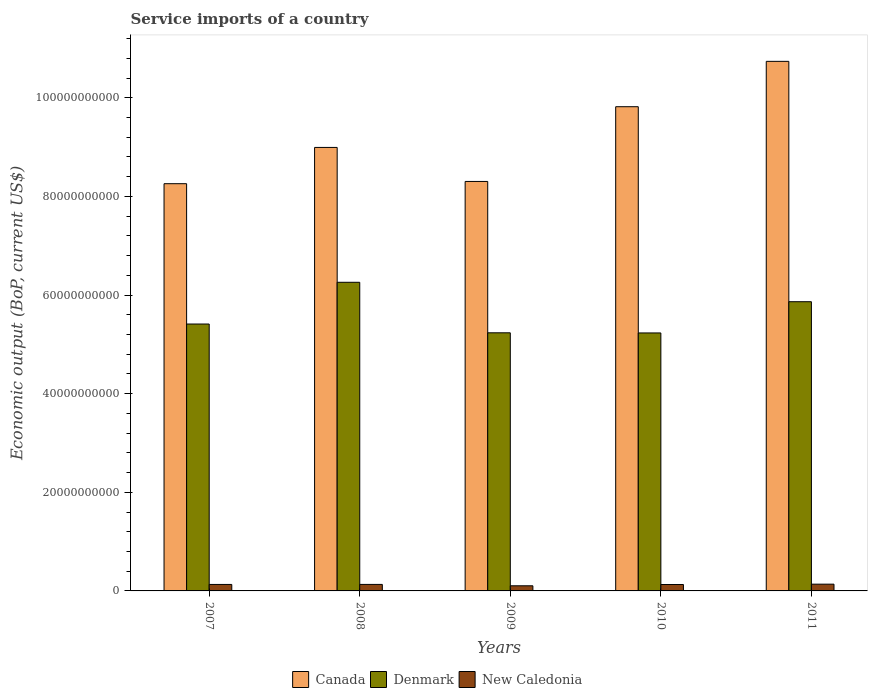How many different coloured bars are there?
Offer a very short reply. 3. Are the number of bars per tick equal to the number of legend labels?
Offer a terse response. Yes. How many bars are there on the 3rd tick from the left?
Give a very brief answer. 3. In how many cases, is the number of bars for a given year not equal to the number of legend labels?
Offer a very short reply. 0. What is the service imports in New Caledonia in 2008?
Provide a succinct answer. 1.32e+09. Across all years, what is the maximum service imports in New Caledonia?
Give a very brief answer. 1.37e+09. Across all years, what is the minimum service imports in New Caledonia?
Your answer should be compact. 1.04e+09. In which year was the service imports in New Caledonia maximum?
Provide a succinct answer. 2011. In which year was the service imports in New Caledonia minimum?
Your answer should be compact. 2009. What is the total service imports in New Caledonia in the graph?
Give a very brief answer. 6.34e+09. What is the difference between the service imports in New Caledonia in 2009 and that in 2010?
Provide a succinct answer. -2.60e+08. What is the difference between the service imports in New Caledonia in 2008 and the service imports in Denmark in 2011?
Give a very brief answer. -5.73e+1. What is the average service imports in Denmark per year?
Provide a succinct answer. 5.60e+1. In the year 2009, what is the difference between the service imports in New Caledonia and service imports in Denmark?
Give a very brief answer. -5.13e+1. In how many years, is the service imports in New Caledonia greater than 104000000000 US$?
Provide a succinct answer. 0. What is the ratio of the service imports in Denmark in 2009 to that in 2010?
Your answer should be very brief. 1. Is the difference between the service imports in New Caledonia in 2009 and 2010 greater than the difference between the service imports in Denmark in 2009 and 2010?
Your response must be concise. No. What is the difference between the highest and the second highest service imports in New Caledonia?
Give a very brief answer. 5.25e+07. What is the difference between the highest and the lowest service imports in New Caledonia?
Your answer should be very brief. 3.31e+08. What does the 1st bar from the left in 2011 represents?
Make the answer very short. Canada. How many bars are there?
Your response must be concise. 15. Are all the bars in the graph horizontal?
Provide a succinct answer. No. How many years are there in the graph?
Offer a very short reply. 5. What is the difference between two consecutive major ticks on the Y-axis?
Provide a short and direct response. 2.00e+1. Are the values on the major ticks of Y-axis written in scientific E-notation?
Provide a succinct answer. No. Does the graph contain grids?
Provide a succinct answer. No. How are the legend labels stacked?
Your answer should be compact. Horizontal. What is the title of the graph?
Make the answer very short. Service imports of a country. What is the label or title of the X-axis?
Provide a succinct answer. Years. What is the label or title of the Y-axis?
Make the answer very short. Economic output (BoP, current US$). What is the Economic output (BoP, current US$) in Canada in 2007?
Keep it short and to the point. 8.26e+1. What is the Economic output (BoP, current US$) in Denmark in 2007?
Offer a very short reply. 5.41e+1. What is the Economic output (BoP, current US$) of New Caledonia in 2007?
Your answer should be compact. 1.31e+09. What is the Economic output (BoP, current US$) in Canada in 2008?
Offer a terse response. 8.99e+1. What is the Economic output (BoP, current US$) of Denmark in 2008?
Offer a very short reply. 6.26e+1. What is the Economic output (BoP, current US$) of New Caledonia in 2008?
Give a very brief answer. 1.32e+09. What is the Economic output (BoP, current US$) in Canada in 2009?
Keep it short and to the point. 8.30e+1. What is the Economic output (BoP, current US$) in Denmark in 2009?
Provide a succinct answer. 5.23e+1. What is the Economic output (BoP, current US$) of New Caledonia in 2009?
Your answer should be very brief. 1.04e+09. What is the Economic output (BoP, current US$) in Canada in 2010?
Provide a succinct answer. 9.82e+1. What is the Economic output (BoP, current US$) of Denmark in 2010?
Ensure brevity in your answer.  5.23e+1. What is the Economic output (BoP, current US$) in New Caledonia in 2010?
Provide a short and direct response. 1.30e+09. What is the Economic output (BoP, current US$) in Canada in 2011?
Ensure brevity in your answer.  1.07e+11. What is the Economic output (BoP, current US$) in Denmark in 2011?
Your response must be concise. 5.86e+1. What is the Economic output (BoP, current US$) of New Caledonia in 2011?
Your answer should be very brief. 1.37e+09. Across all years, what is the maximum Economic output (BoP, current US$) of Canada?
Make the answer very short. 1.07e+11. Across all years, what is the maximum Economic output (BoP, current US$) in Denmark?
Your answer should be very brief. 6.26e+1. Across all years, what is the maximum Economic output (BoP, current US$) in New Caledonia?
Your answer should be compact. 1.37e+09. Across all years, what is the minimum Economic output (BoP, current US$) in Canada?
Provide a short and direct response. 8.26e+1. Across all years, what is the minimum Economic output (BoP, current US$) of Denmark?
Make the answer very short. 5.23e+1. Across all years, what is the minimum Economic output (BoP, current US$) in New Caledonia?
Provide a short and direct response. 1.04e+09. What is the total Economic output (BoP, current US$) of Canada in the graph?
Your response must be concise. 4.61e+11. What is the total Economic output (BoP, current US$) in Denmark in the graph?
Offer a terse response. 2.80e+11. What is the total Economic output (BoP, current US$) of New Caledonia in the graph?
Ensure brevity in your answer.  6.34e+09. What is the difference between the Economic output (BoP, current US$) of Canada in 2007 and that in 2008?
Your answer should be very brief. -7.35e+09. What is the difference between the Economic output (BoP, current US$) of Denmark in 2007 and that in 2008?
Ensure brevity in your answer.  -8.46e+09. What is the difference between the Economic output (BoP, current US$) in New Caledonia in 2007 and that in 2008?
Your answer should be compact. -4.93e+06. What is the difference between the Economic output (BoP, current US$) of Canada in 2007 and that in 2009?
Make the answer very short. -4.55e+08. What is the difference between the Economic output (BoP, current US$) in Denmark in 2007 and that in 2009?
Provide a succinct answer. 1.78e+09. What is the difference between the Economic output (BoP, current US$) of New Caledonia in 2007 and that in 2009?
Ensure brevity in your answer.  2.73e+08. What is the difference between the Economic output (BoP, current US$) of Canada in 2007 and that in 2010?
Ensure brevity in your answer.  -1.56e+1. What is the difference between the Economic output (BoP, current US$) of Denmark in 2007 and that in 2010?
Your answer should be very brief. 1.81e+09. What is the difference between the Economic output (BoP, current US$) of New Caledonia in 2007 and that in 2010?
Offer a very short reply. 1.29e+07. What is the difference between the Economic output (BoP, current US$) of Canada in 2007 and that in 2011?
Keep it short and to the point. -2.48e+1. What is the difference between the Economic output (BoP, current US$) of Denmark in 2007 and that in 2011?
Offer a very short reply. -4.52e+09. What is the difference between the Economic output (BoP, current US$) of New Caledonia in 2007 and that in 2011?
Your answer should be very brief. -5.75e+07. What is the difference between the Economic output (BoP, current US$) in Canada in 2008 and that in 2009?
Your answer should be compact. 6.90e+09. What is the difference between the Economic output (BoP, current US$) in Denmark in 2008 and that in 2009?
Provide a succinct answer. 1.02e+1. What is the difference between the Economic output (BoP, current US$) in New Caledonia in 2008 and that in 2009?
Provide a succinct answer. 2.78e+08. What is the difference between the Economic output (BoP, current US$) of Canada in 2008 and that in 2010?
Give a very brief answer. -8.25e+09. What is the difference between the Economic output (BoP, current US$) in Denmark in 2008 and that in 2010?
Your response must be concise. 1.03e+1. What is the difference between the Economic output (BoP, current US$) of New Caledonia in 2008 and that in 2010?
Your answer should be very brief. 1.78e+07. What is the difference between the Economic output (BoP, current US$) of Canada in 2008 and that in 2011?
Offer a terse response. -1.75e+1. What is the difference between the Economic output (BoP, current US$) in Denmark in 2008 and that in 2011?
Your response must be concise. 3.94e+09. What is the difference between the Economic output (BoP, current US$) of New Caledonia in 2008 and that in 2011?
Offer a very short reply. -5.25e+07. What is the difference between the Economic output (BoP, current US$) in Canada in 2009 and that in 2010?
Your answer should be compact. -1.52e+1. What is the difference between the Economic output (BoP, current US$) in Denmark in 2009 and that in 2010?
Your answer should be very brief. 2.79e+07. What is the difference between the Economic output (BoP, current US$) of New Caledonia in 2009 and that in 2010?
Your answer should be compact. -2.60e+08. What is the difference between the Economic output (BoP, current US$) in Canada in 2009 and that in 2011?
Your response must be concise. -2.44e+1. What is the difference between the Economic output (BoP, current US$) of Denmark in 2009 and that in 2011?
Your answer should be compact. -6.30e+09. What is the difference between the Economic output (BoP, current US$) of New Caledonia in 2009 and that in 2011?
Give a very brief answer. -3.31e+08. What is the difference between the Economic output (BoP, current US$) of Canada in 2010 and that in 2011?
Your answer should be very brief. -9.20e+09. What is the difference between the Economic output (BoP, current US$) of Denmark in 2010 and that in 2011?
Keep it short and to the point. -6.33e+09. What is the difference between the Economic output (BoP, current US$) in New Caledonia in 2010 and that in 2011?
Give a very brief answer. -7.04e+07. What is the difference between the Economic output (BoP, current US$) in Canada in 2007 and the Economic output (BoP, current US$) in Denmark in 2008?
Offer a very short reply. 2.00e+1. What is the difference between the Economic output (BoP, current US$) in Canada in 2007 and the Economic output (BoP, current US$) in New Caledonia in 2008?
Offer a terse response. 8.13e+1. What is the difference between the Economic output (BoP, current US$) in Denmark in 2007 and the Economic output (BoP, current US$) in New Caledonia in 2008?
Offer a very short reply. 5.28e+1. What is the difference between the Economic output (BoP, current US$) in Canada in 2007 and the Economic output (BoP, current US$) in Denmark in 2009?
Your response must be concise. 3.02e+1. What is the difference between the Economic output (BoP, current US$) in Canada in 2007 and the Economic output (BoP, current US$) in New Caledonia in 2009?
Your response must be concise. 8.15e+1. What is the difference between the Economic output (BoP, current US$) of Denmark in 2007 and the Economic output (BoP, current US$) of New Caledonia in 2009?
Provide a succinct answer. 5.31e+1. What is the difference between the Economic output (BoP, current US$) in Canada in 2007 and the Economic output (BoP, current US$) in Denmark in 2010?
Give a very brief answer. 3.03e+1. What is the difference between the Economic output (BoP, current US$) in Canada in 2007 and the Economic output (BoP, current US$) in New Caledonia in 2010?
Offer a terse response. 8.13e+1. What is the difference between the Economic output (BoP, current US$) in Denmark in 2007 and the Economic output (BoP, current US$) in New Caledonia in 2010?
Offer a very short reply. 5.28e+1. What is the difference between the Economic output (BoP, current US$) in Canada in 2007 and the Economic output (BoP, current US$) in Denmark in 2011?
Your response must be concise. 2.39e+1. What is the difference between the Economic output (BoP, current US$) of Canada in 2007 and the Economic output (BoP, current US$) of New Caledonia in 2011?
Your answer should be very brief. 8.12e+1. What is the difference between the Economic output (BoP, current US$) of Denmark in 2007 and the Economic output (BoP, current US$) of New Caledonia in 2011?
Offer a very short reply. 5.27e+1. What is the difference between the Economic output (BoP, current US$) of Canada in 2008 and the Economic output (BoP, current US$) of Denmark in 2009?
Your answer should be very brief. 3.76e+1. What is the difference between the Economic output (BoP, current US$) in Canada in 2008 and the Economic output (BoP, current US$) in New Caledonia in 2009?
Offer a terse response. 8.89e+1. What is the difference between the Economic output (BoP, current US$) of Denmark in 2008 and the Economic output (BoP, current US$) of New Caledonia in 2009?
Your answer should be very brief. 6.15e+1. What is the difference between the Economic output (BoP, current US$) of Canada in 2008 and the Economic output (BoP, current US$) of Denmark in 2010?
Provide a succinct answer. 3.76e+1. What is the difference between the Economic output (BoP, current US$) in Canada in 2008 and the Economic output (BoP, current US$) in New Caledonia in 2010?
Offer a terse response. 8.86e+1. What is the difference between the Economic output (BoP, current US$) in Denmark in 2008 and the Economic output (BoP, current US$) in New Caledonia in 2010?
Your response must be concise. 6.13e+1. What is the difference between the Economic output (BoP, current US$) in Canada in 2008 and the Economic output (BoP, current US$) in Denmark in 2011?
Give a very brief answer. 3.13e+1. What is the difference between the Economic output (BoP, current US$) in Canada in 2008 and the Economic output (BoP, current US$) in New Caledonia in 2011?
Your response must be concise. 8.86e+1. What is the difference between the Economic output (BoP, current US$) in Denmark in 2008 and the Economic output (BoP, current US$) in New Caledonia in 2011?
Keep it short and to the point. 6.12e+1. What is the difference between the Economic output (BoP, current US$) in Canada in 2009 and the Economic output (BoP, current US$) in Denmark in 2010?
Ensure brevity in your answer.  3.07e+1. What is the difference between the Economic output (BoP, current US$) of Canada in 2009 and the Economic output (BoP, current US$) of New Caledonia in 2010?
Offer a very short reply. 8.17e+1. What is the difference between the Economic output (BoP, current US$) of Denmark in 2009 and the Economic output (BoP, current US$) of New Caledonia in 2010?
Your answer should be very brief. 5.10e+1. What is the difference between the Economic output (BoP, current US$) of Canada in 2009 and the Economic output (BoP, current US$) of Denmark in 2011?
Offer a very short reply. 2.44e+1. What is the difference between the Economic output (BoP, current US$) of Canada in 2009 and the Economic output (BoP, current US$) of New Caledonia in 2011?
Offer a very short reply. 8.17e+1. What is the difference between the Economic output (BoP, current US$) of Denmark in 2009 and the Economic output (BoP, current US$) of New Caledonia in 2011?
Make the answer very short. 5.10e+1. What is the difference between the Economic output (BoP, current US$) in Canada in 2010 and the Economic output (BoP, current US$) in Denmark in 2011?
Provide a short and direct response. 3.95e+1. What is the difference between the Economic output (BoP, current US$) in Canada in 2010 and the Economic output (BoP, current US$) in New Caledonia in 2011?
Ensure brevity in your answer.  9.68e+1. What is the difference between the Economic output (BoP, current US$) of Denmark in 2010 and the Economic output (BoP, current US$) of New Caledonia in 2011?
Offer a terse response. 5.09e+1. What is the average Economic output (BoP, current US$) of Canada per year?
Provide a succinct answer. 9.22e+1. What is the average Economic output (BoP, current US$) in Denmark per year?
Your answer should be compact. 5.60e+1. What is the average Economic output (BoP, current US$) in New Caledonia per year?
Make the answer very short. 1.27e+09. In the year 2007, what is the difference between the Economic output (BoP, current US$) in Canada and Economic output (BoP, current US$) in Denmark?
Your response must be concise. 2.85e+1. In the year 2007, what is the difference between the Economic output (BoP, current US$) in Canada and Economic output (BoP, current US$) in New Caledonia?
Keep it short and to the point. 8.13e+1. In the year 2007, what is the difference between the Economic output (BoP, current US$) in Denmark and Economic output (BoP, current US$) in New Caledonia?
Make the answer very short. 5.28e+1. In the year 2008, what is the difference between the Economic output (BoP, current US$) of Canada and Economic output (BoP, current US$) of Denmark?
Provide a succinct answer. 2.73e+1. In the year 2008, what is the difference between the Economic output (BoP, current US$) in Canada and Economic output (BoP, current US$) in New Caledonia?
Ensure brevity in your answer.  8.86e+1. In the year 2008, what is the difference between the Economic output (BoP, current US$) of Denmark and Economic output (BoP, current US$) of New Caledonia?
Your answer should be very brief. 6.13e+1. In the year 2009, what is the difference between the Economic output (BoP, current US$) in Canada and Economic output (BoP, current US$) in Denmark?
Provide a succinct answer. 3.07e+1. In the year 2009, what is the difference between the Economic output (BoP, current US$) in Canada and Economic output (BoP, current US$) in New Caledonia?
Make the answer very short. 8.20e+1. In the year 2009, what is the difference between the Economic output (BoP, current US$) of Denmark and Economic output (BoP, current US$) of New Caledonia?
Your answer should be compact. 5.13e+1. In the year 2010, what is the difference between the Economic output (BoP, current US$) of Canada and Economic output (BoP, current US$) of Denmark?
Provide a succinct answer. 4.59e+1. In the year 2010, what is the difference between the Economic output (BoP, current US$) of Canada and Economic output (BoP, current US$) of New Caledonia?
Provide a succinct answer. 9.69e+1. In the year 2010, what is the difference between the Economic output (BoP, current US$) of Denmark and Economic output (BoP, current US$) of New Caledonia?
Ensure brevity in your answer.  5.10e+1. In the year 2011, what is the difference between the Economic output (BoP, current US$) in Canada and Economic output (BoP, current US$) in Denmark?
Provide a succinct answer. 4.87e+1. In the year 2011, what is the difference between the Economic output (BoP, current US$) in Canada and Economic output (BoP, current US$) in New Caledonia?
Keep it short and to the point. 1.06e+11. In the year 2011, what is the difference between the Economic output (BoP, current US$) of Denmark and Economic output (BoP, current US$) of New Caledonia?
Provide a succinct answer. 5.73e+1. What is the ratio of the Economic output (BoP, current US$) in Canada in 2007 to that in 2008?
Provide a short and direct response. 0.92. What is the ratio of the Economic output (BoP, current US$) of Denmark in 2007 to that in 2008?
Provide a short and direct response. 0.86. What is the ratio of the Economic output (BoP, current US$) of Denmark in 2007 to that in 2009?
Make the answer very short. 1.03. What is the ratio of the Economic output (BoP, current US$) in New Caledonia in 2007 to that in 2009?
Offer a terse response. 1.26. What is the ratio of the Economic output (BoP, current US$) of Canada in 2007 to that in 2010?
Give a very brief answer. 0.84. What is the ratio of the Economic output (BoP, current US$) in Denmark in 2007 to that in 2010?
Offer a very short reply. 1.03. What is the ratio of the Economic output (BoP, current US$) of New Caledonia in 2007 to that in 2010?
Give a very brief answer. 1.01. What is the ratio of the Economic output (BoP, current US$) of Canada in 2007 to that in 2011?
Ensure brevity in your answer.  0.77. What is the ratio of the Economic output (BoP, current US$) of Denmark in 2007 to that in 2011?
Your answer should be very brief. 0.92. What is the ratio of the Economic output (BoP, current US$) of New Caledonia in 2007 to that in 2011?
Give a very brief answer. 0.96. What is the ratio of the Economic output (BoP, current US$) in Canada in 2008 to that in 2009?
Give a very brief answer. 1.08. What is the ratio of the Economic output (BoP, current US$) in Denmark in 2008 to that in 2009?
Provide a succinct answer. 1.2. What is the ratio of the Economic output (BoP, current US$) in New Caledonia in 2008 to that in 2009?
Give a very brief answer. 1.27. What is the ratio of the Economic output (BoP, current US$) of Canada in 2008 to that in 2010?
Your answer should be compact. 0.92. What is the ratio of the Economic output (BoP, current US$) in Denmark in 2008 to that in 2010?
Your answer should be very brief. 1.2. What is the ratio of the Economic output (BoP, current US$) in New Caledonia in 2008 to that in 2010?
Give a very brief answer. 1.01. What is the ratio of the Economic output (BoP, current US$) of Canada in 2008 to that in 2011?
Your answer should be very brief. 0.84. What is the ratio of the Economic output (BoP, current US$) in Denmark in 2008 to that in 2011?
Your answer should be compact. 1.07. What is the ratio of the Economic output (BoP, current US$) in New Caledonia in 2008 to that in 2011?
Offer a very short reply. 0.96. What is the ratio of the Economic output (BoP, current US$) in Canada in 2009 to that in 2010?
Make the answer very short. 0.85. What is the ratio of the Economic output (BoP, current US$) of Denmark in 2009 to that in 2010?
Make the answer very short. 1. What is the ratio of the Economic output (BoP, current US$) of Canada in 2009 to that in 2011?
Your answer should be very brief. 0.77. What is the ratio of the Economic output (BoP, current US$) in Denmark in 2009 to that in 2011?
Offer a terse response. 0.89. What is the ratio of the Economic output (BoP, current US$) in New Caledonia in 2009 to that in 2011?
Make the answer very short. 0.76. What is the ratio of the Economic output (BoP, current US$) of Canada in 2010 to that in 2011?
Make the answer very short. 0.91. What is the ratio of the Economic output (BoP, current US$) in Denmark in 2010 to that in 2011?
Your answer should be compact. 0.89. What is the ratio of the Economic output (BoP, current US$) of New Caledonia in 2010 to that in 2011?
Give a very brief answer. 0.95. What is the difference between the highest and the second highest Economic output (BoP, current US$) in Canada?
Provide a succinct answer. 9.20e+09. What is the difference between the highest and the second highest Economic output (BoP, current US$) of Denmark?
Offer a terse response. 3.94e+09. What is the difference between the highest and the second highest Economic output (BoP, current US$) of New Caledonia?
Make the answer very short. 5.25e+07. What is the difference between the highest and the lowest Economic output (BoP, current US$) in Canada?
Keep it short and to the point. 2.48e+1. What is the difference between the highest and the lowest Economic output (BoP, current US$) of Denmark?
Offer a very short reply. 1.03e+1. What is the difference between the highest and the lowest Economic output (BoP, current US$) of New Caledonia?
Ensure brevity in your answer.  3.31e+08. 